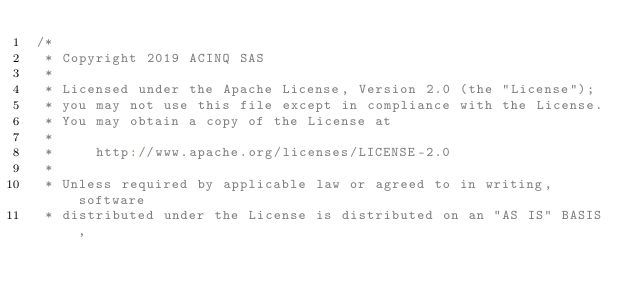Convert code to text. <code><loc_0><loc_0><loc_500><loc_500><_Scala_>/*
 * Copyright 2019 ACINQ SAS
 *
 * Licensed under the Apache License, Version 2.0 (the "License");
 * you may not use this file except in compliance with the License.
 * You may obtain a copy of the License at
 *
 *     http://www.apache.org/licenses/LICENSE-2.0
 *
 * Unless required by applicable law or agreed to in writing, software
 * distributed under the License is distributed on an "AS IS" BASIS,</code> 